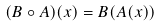Convert formula to latex. <formula><loc_0><loc_0><loc_500><loc_500>( B \circ A ) ( x ) = B ( A ( x ) )</formula> 